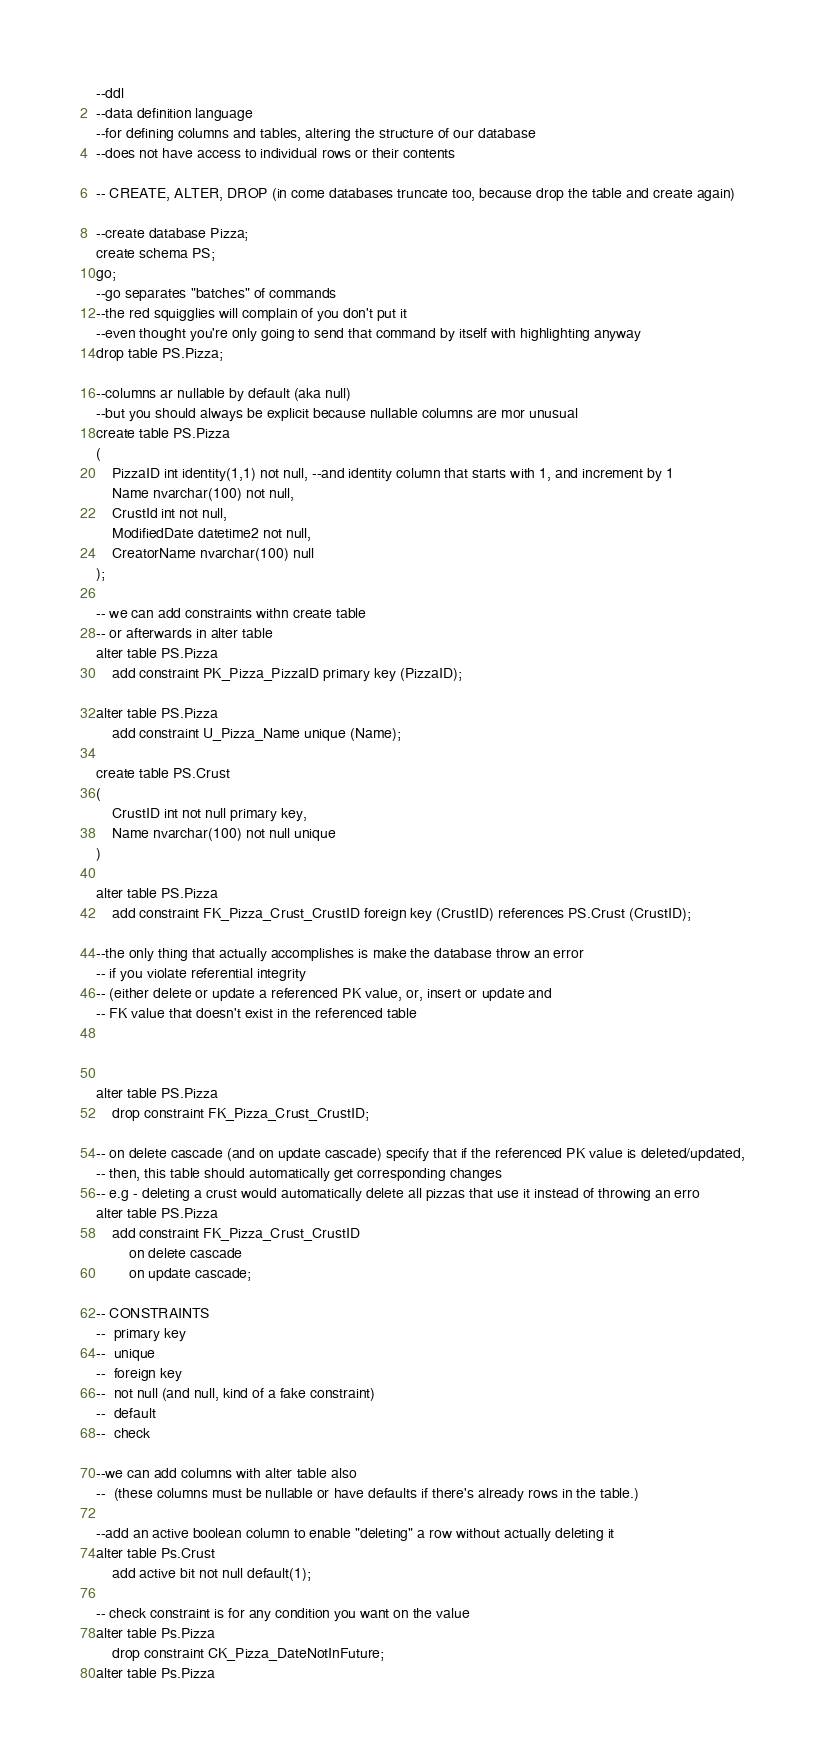Convert code to text. <code><loc_0><loc_0><loc_500><loc_500><_SQL_>--ddl
--data definition language
--for defining columns and tables, altering the structure of our database
--does not have access to individual rows or their contents

-- CREATE, ALTER, DROP (in come databases truncate too, because drop the table and create again)

--create database Pizza;
create schema PS;
go;
--go separates "batches" of commands
--the red squigglies will complain of you don't put it
--even thought you're only going to send that command by itself with highlighting anyway
drop table PS.Pizza;

--columns ar nullable by default (aka null)
--but you should always be explicit because nullable columns are mor unusual
create table PS.Pizza
(
	PizzaID int identity(1,1) not null, --and identity column that starts with 1, and increment by 1
	Name nvarchar(100) not null,
	CrustId int not null,
	ModifiedDate datetime2 not null,
	CreatorName nvarchar(100) null
);

-- we can add constraints withn create table
-- or afterwards in alter table
alter table PS.Pizza
	add constraint PK_Pizza_PizzaID primary key (PizzaID);

alter table PS.Pizza
	add constraint U_Pizza_Name unique (Name);

create table PS.Crust
(
	CrustID int not null primary key,
	Name nvarchar(100) not null unique
)

alter table PS.Pizza
	add constraint FK_Pizza_Crust_CrustID foreign key (CrustID) references PS.Crust (CrustID);

--the only thing that actually accomplishes is make the database throw an error
-- if you violate referential integrity
-- (either delete or update a referenced PK value, or, insert or update and
-- FK value that doesn't exist in the referenced table



alter table PS.Pizza
	drop constraint FK_Pizza_Crust_CrustID;

-- on delete cascade (and on update cascade) specify that if the referenced PK value is deleted/updated,
-- then, this table should automatically get corresponding changes
-- e.g - deleting a crust would automatically delete all pizzas that use it instead of throwing an erro
alter table PS.Pizza
	add constraint FK_Pizza_Crust_CrustID 
		on delete cascade
		on update cascade;

-- CONSTRAINTS
--	primary key
--	unique
--	foreign key
--	not null (and null, kind of a fake constraint)
--	default
--	check

--we can add columns with alter table also
--	(these columns must be nullable or have defaults if there's already rows in the table.)

--add an active boolean column to enable "deleting" a row without actually deleting it
alter table Ps.Crust
	add active bit not null default(1);

-- check constraint is for any condition you want on the value
alter table Ps.Pizza
	drop constraint CK_Pizza_DateNotInFuture;
alter table Ps.Pizza</code> 